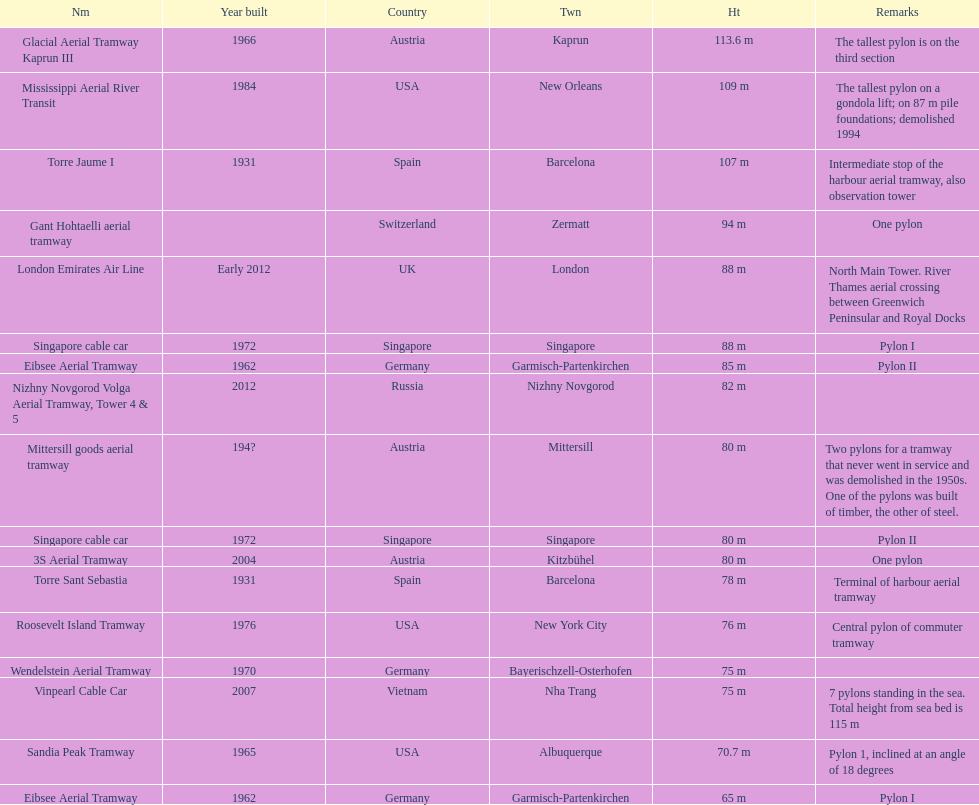List two pylons that are at most, 80 m in height. Mittersill goods aerial tramway, Singapore cable car. 